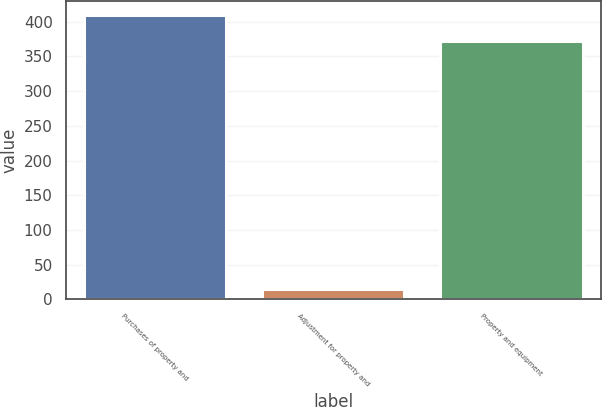Convert chart to OTSL. <chart><loc_0><loc_0><loc_500><loc_500><bar_chart><fcel>Purchases of property and<fcel>Adjustment for property and<fcel>Property and equipment<nl><fcel>409.2<fcel>14.9<fcel>372<nl></chart> 